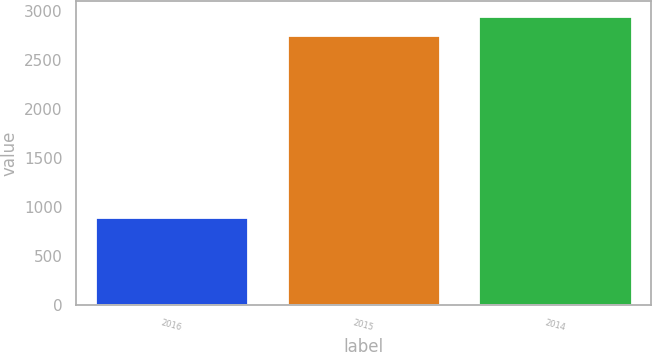Convert chart to OTSL. <chart><loc_0><loc_0><loc_500><loc_500><bar_chart><fcel>2016<fcel>2015<fcel>2014<nl><fcel>902<fcel>2759<fcel>2956.9<nl></chart> 